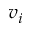Convert formula to latex. <formula><loc_0><loc_0><loc_500><loc_500>v _ { i }</formula> 